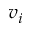Convert formula to latex. <formula><loc_0><loc_0><loc_500><loc_500>v _ { i }</formula> 